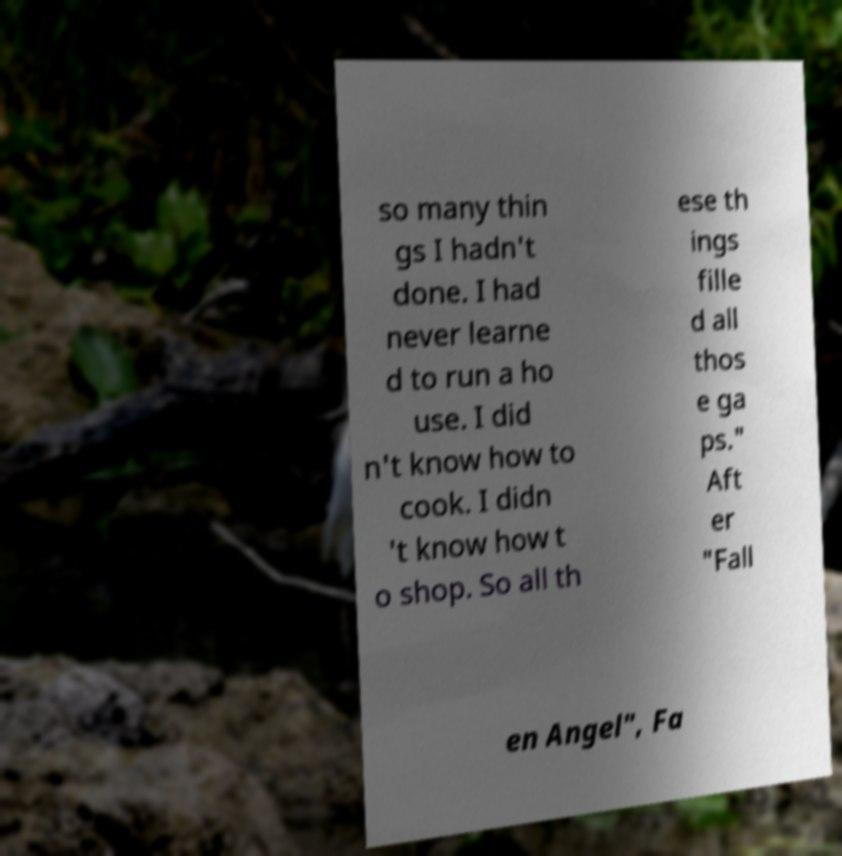Could you extract and type out the text from this image? so many thin gs I hadn't done. I had never learne d to run a ho use. I did n't know how to cook. I didn 't know how t o shop. So all th ese th ings fille d all thos e ga ps." Aft er "Fall en Angel", Fa 